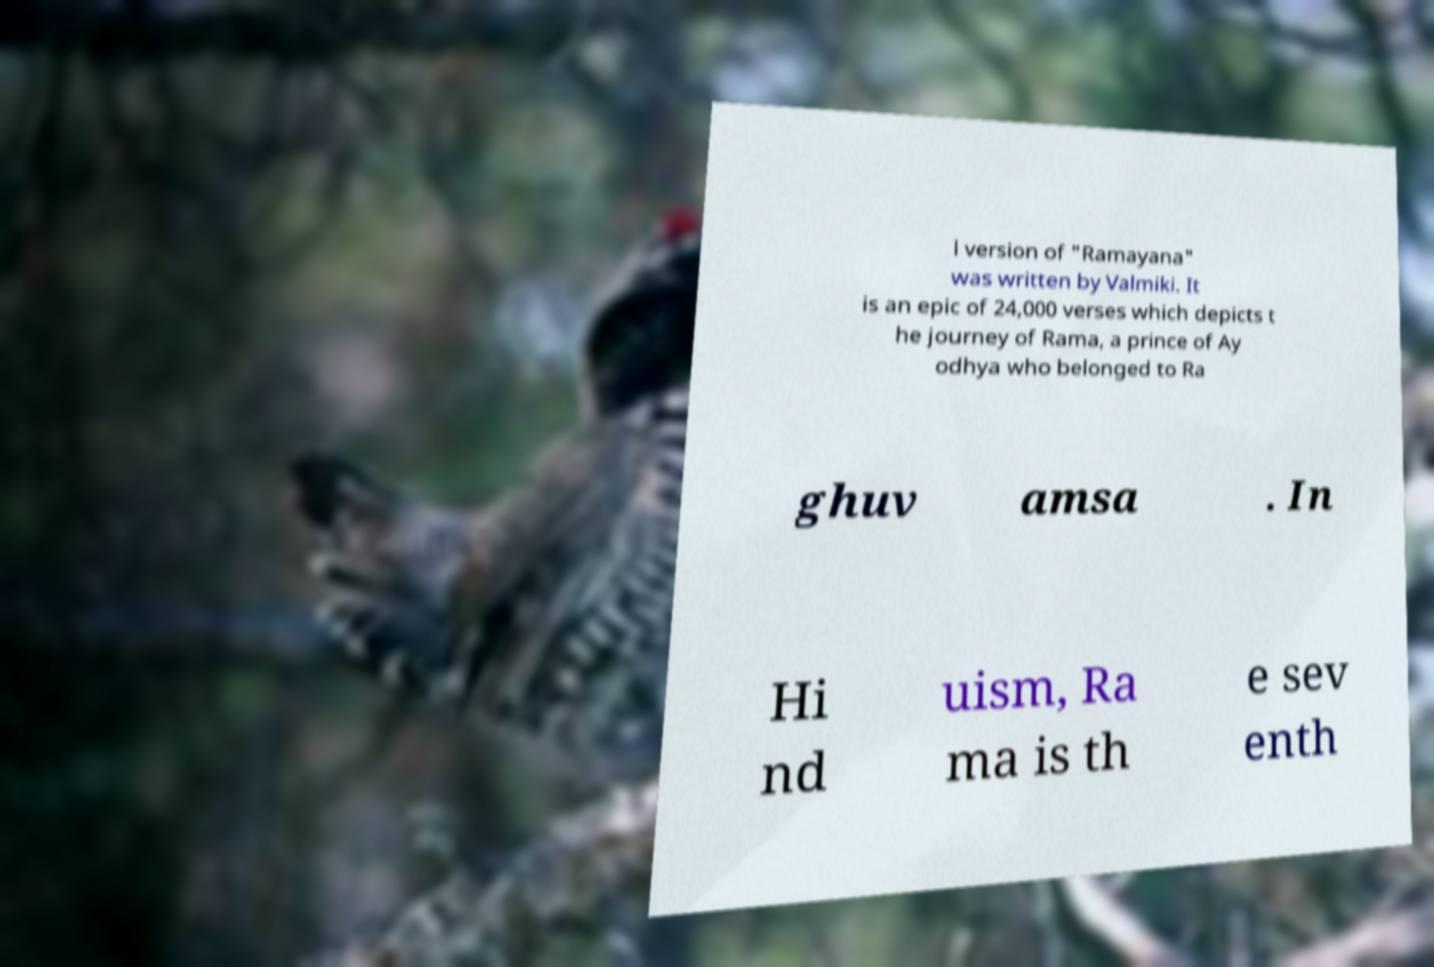Could you assist in decoding the text presented in this image and type it out clearly? l version of "Ramayana" was written by Valmiki. It is an epic of 24,000 verses which depicts t he journey of Rama, a prince of Ay odhya who belonged to Ra ghuv amsa . In Hi nd uism, Ra ma is th e sev enth 